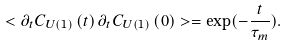<formula> <loc_0><loc_0><loc_500><loc_500>< \partial _ { t } { C } _ { U ( 1 ) } \left ( t \right ) \partial _ { t } { C } _ { U ( 1 ) } \left ( 0 \right ) > = \exp ( - \frac { t } { \tau _ { m } } ) .</formula> 